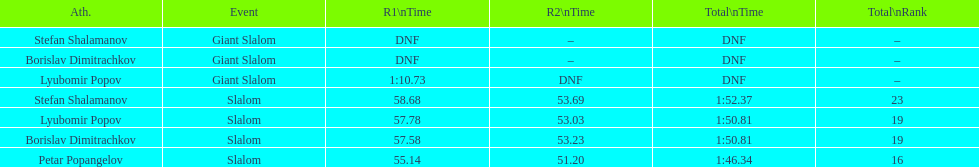Who came after borislav dimitrachkov and it's time for slalom Petar Popangelov. 